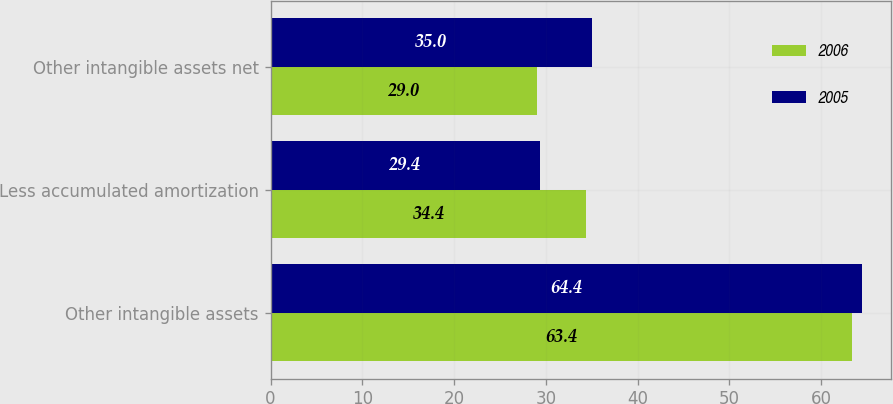<chart> <loc_0><loc_0><loc_500><loc_500><stacked_bar_chart><ecel><fcel>Other intangible assets<fcel>Less accumulated amortization<fcel>Other intangible assets net<nl><fcel>2006<fcel>63.4<fcel>34.4<fcel>29<nl><fcel>2005<fcel>64.4<fcel>29.4<fcel>35<nl></chart> 